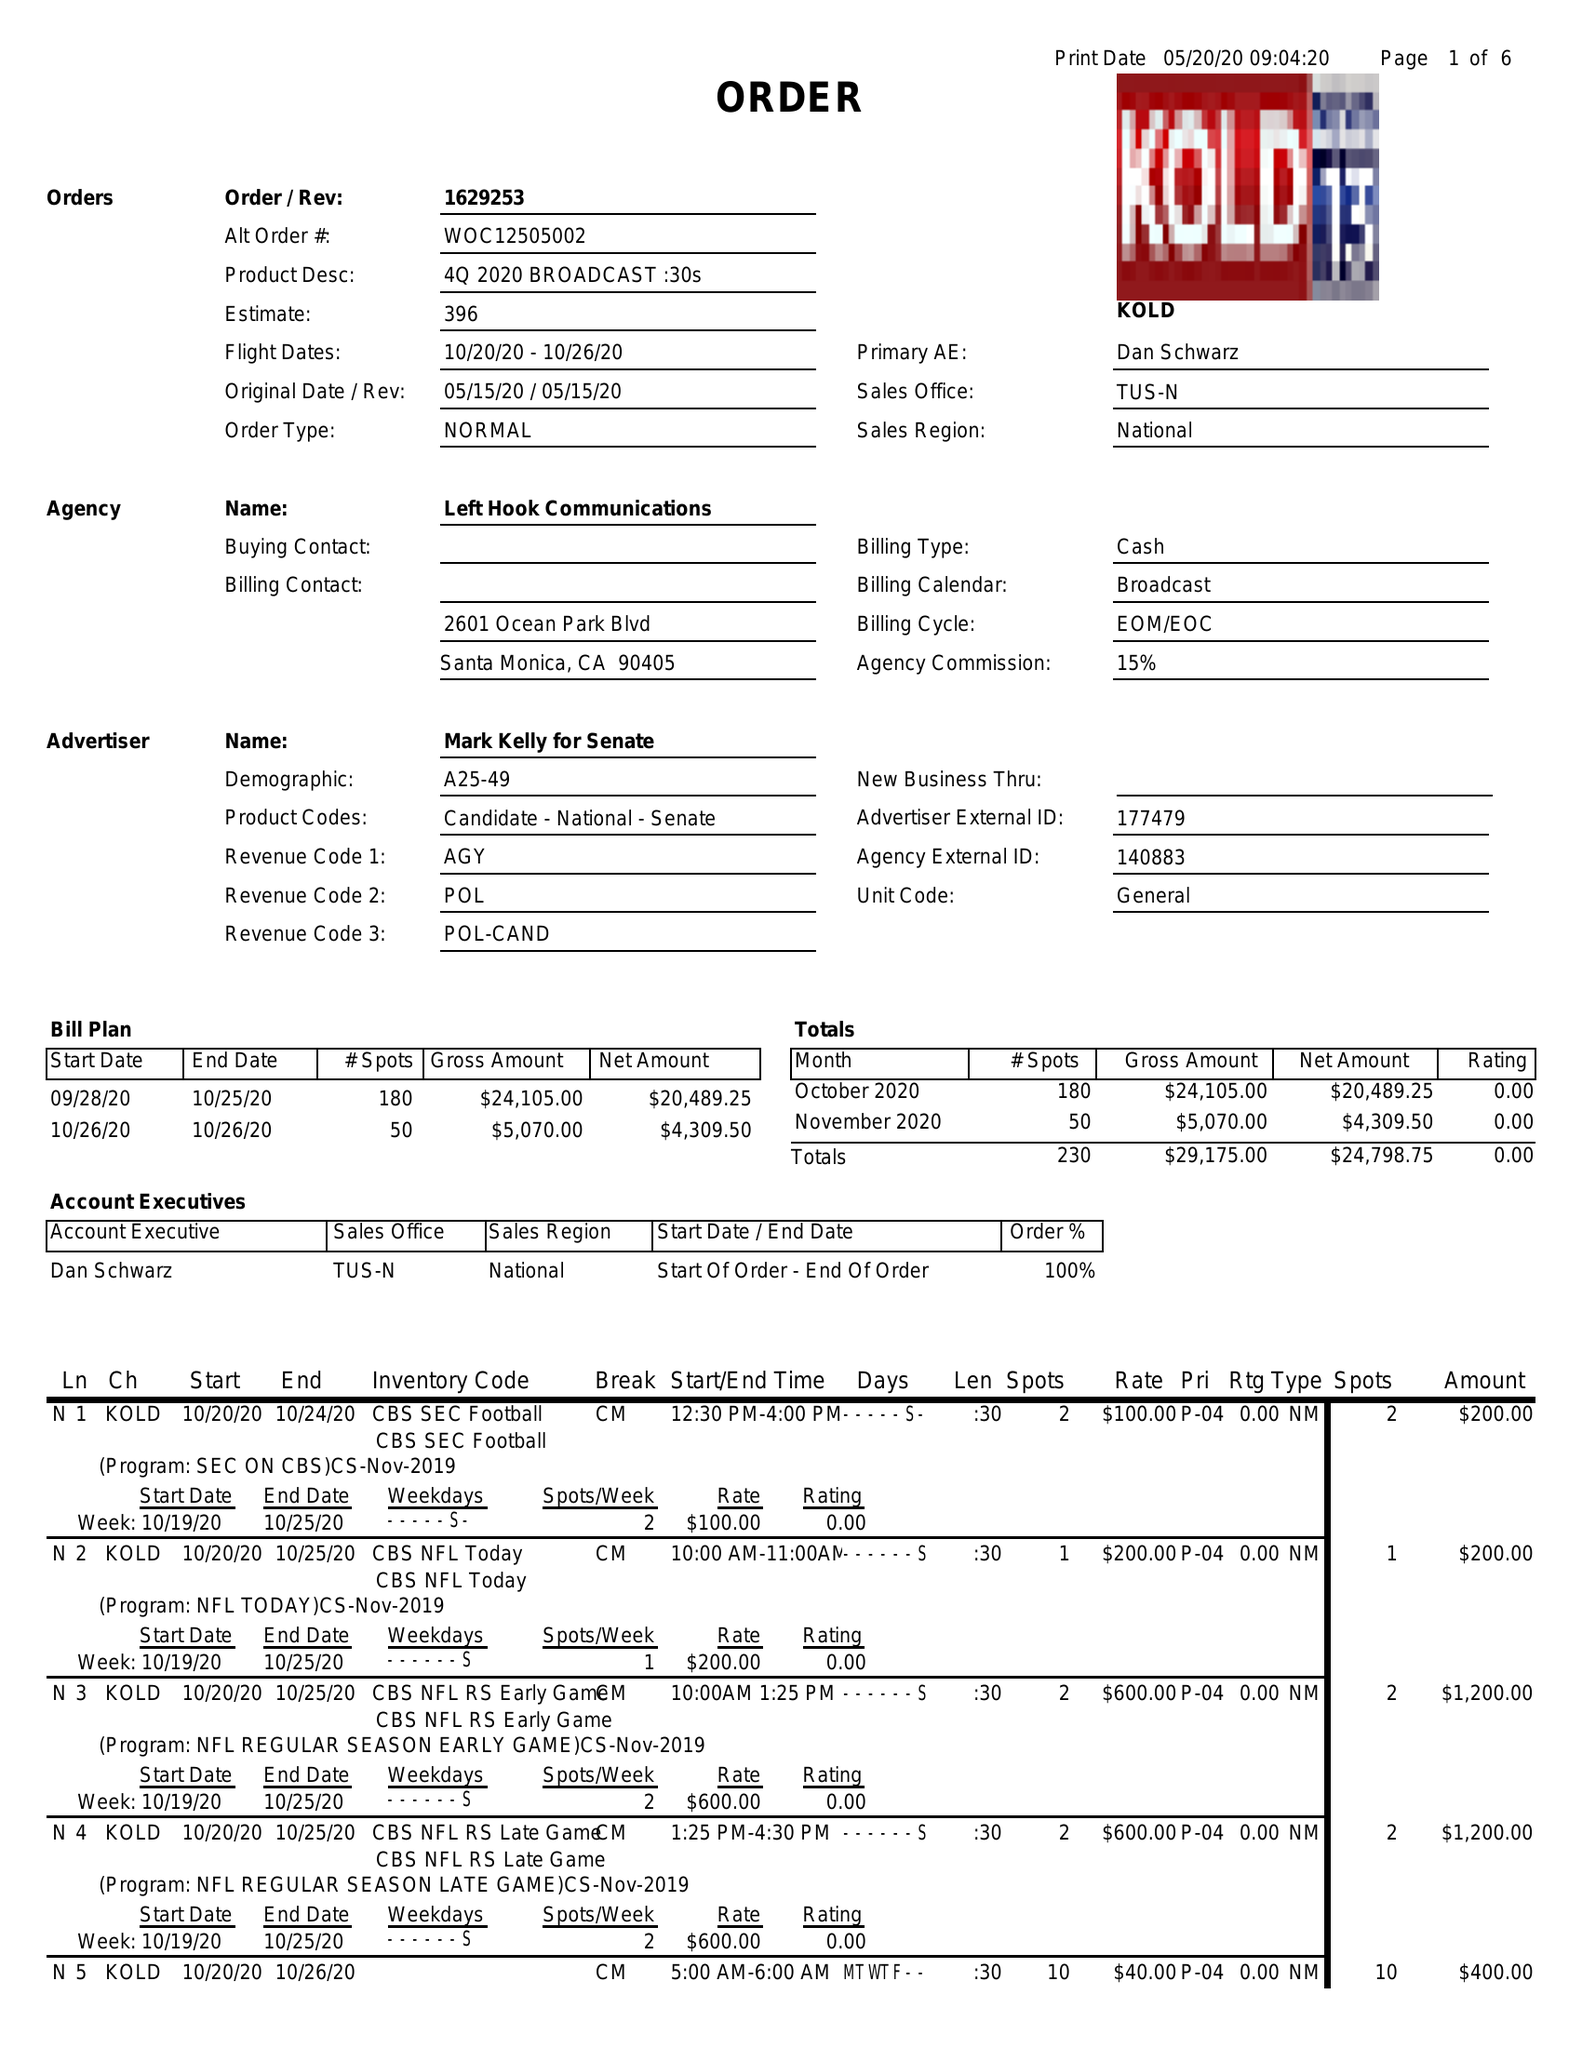What is the value for the advertiser?
Answer the question using a single word or phrase. MARK KELLY FOR SENAT 